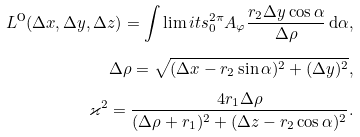Convert formula to latex. <formula><loc_0><loc_0><loc_500><loc_500>L ^ { \text {O} } ( \Delta x , \Delta y , \Delta z ) = \int \lim i t s _ { 0 } ^ { 2 \pi } A _ { \varphi } \frac { r _ { 2 } \Delta y \cos \alpha } { \Delta \rho } \, \mathrm d \alpha , \\ \Delta \rho = \sqrt { ( \Delta x - r _ { 2 } \sin \alpha ) ^ { 2 } + ( \Delta y ) ^ { 2 } } , \\ \varkappa ^ { 2 } = { \frac { 4 r _ { 1 } \Delta \rho } { ( \Delta \rho + r _ { 1 } ) ^ { 2 } + ( \Delta z - r _ { 2 } \cos \alpha ) ^ { 2 } } } .</formula> 